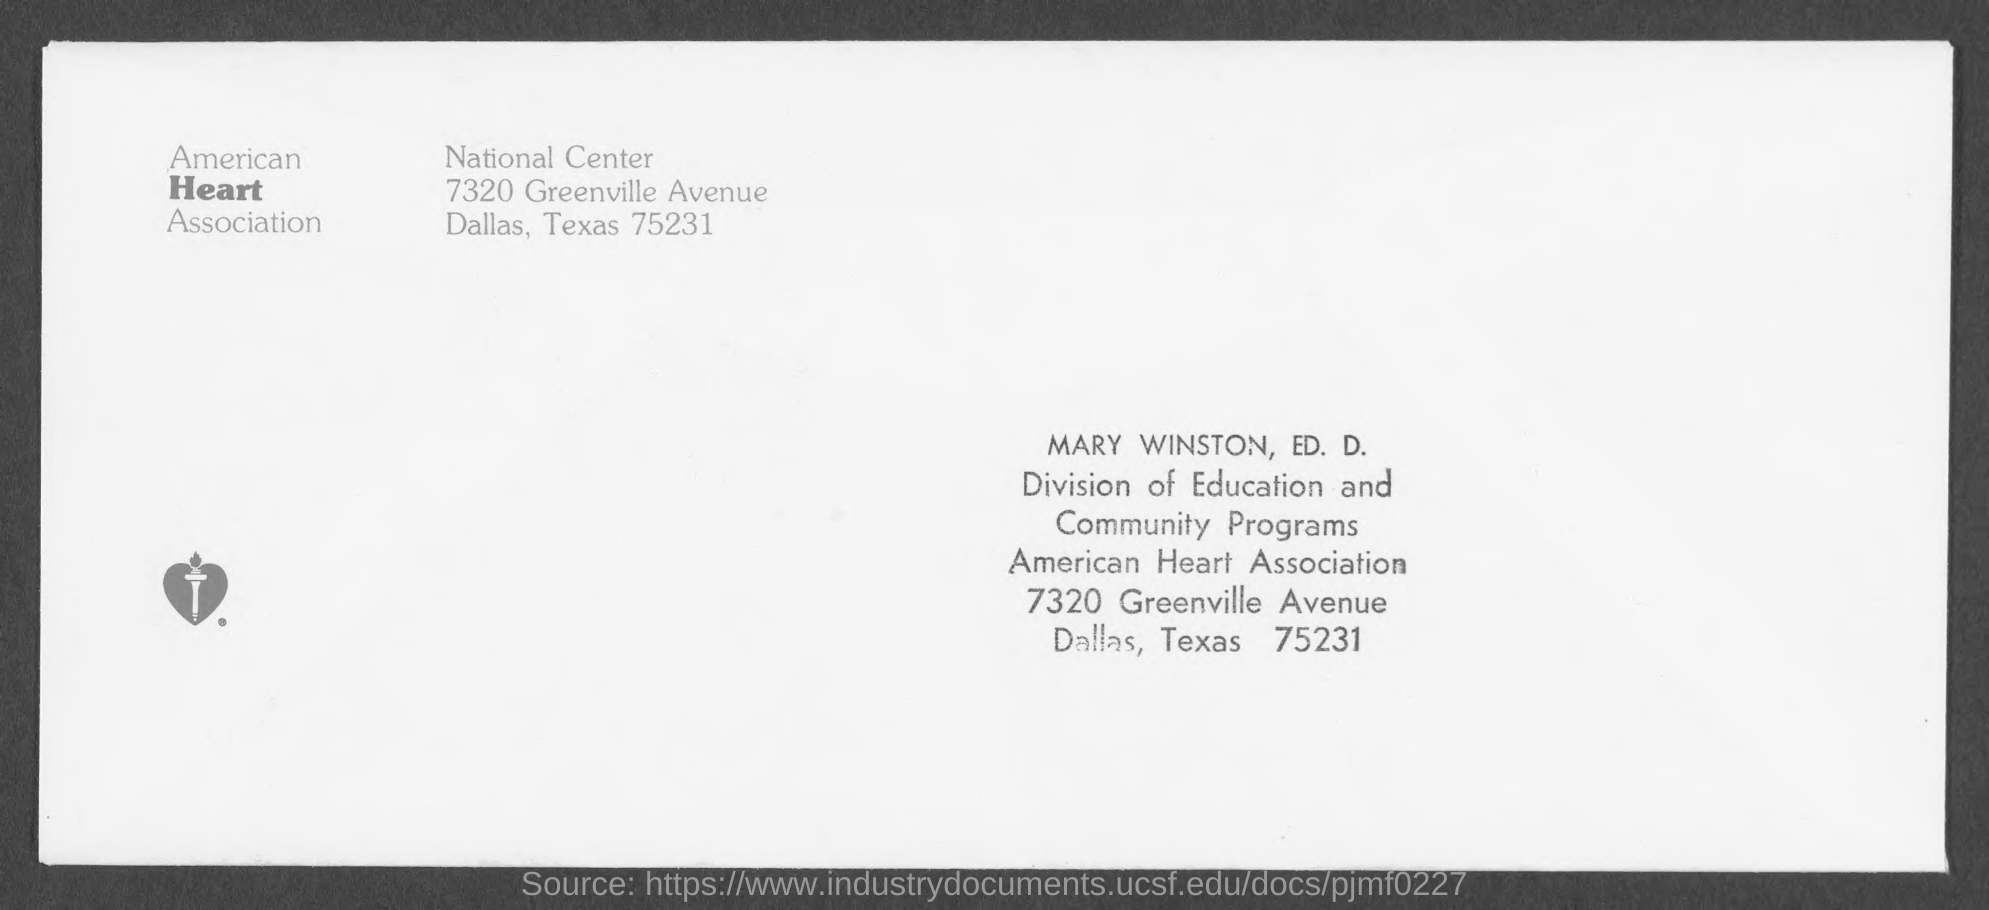To whom this letter is written
Make the answer very short. Mary Winston. In which state and city  american heart association located ?
Give a very brief answer. Dallas , texas. 